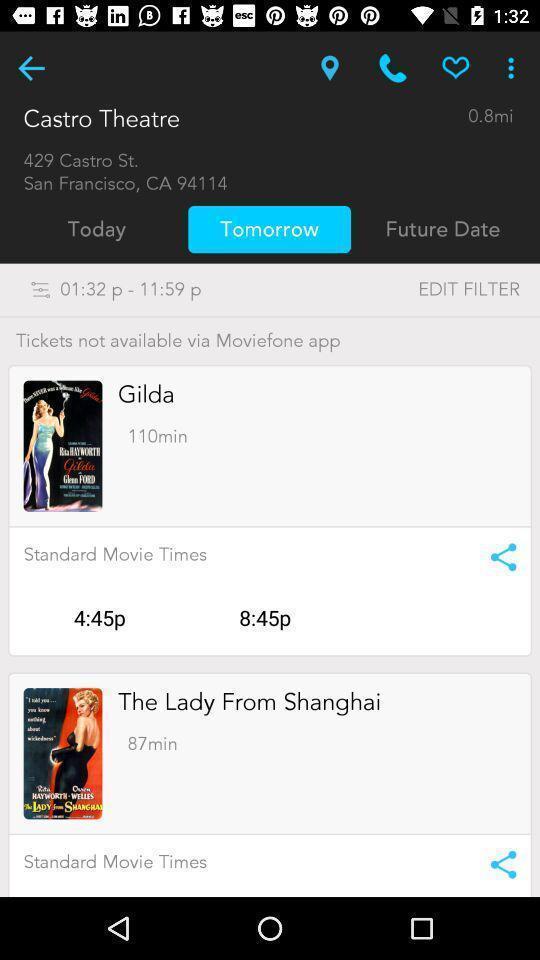Describe the visual elements of this screenshot. Page displaying movies information in a theatre application. 